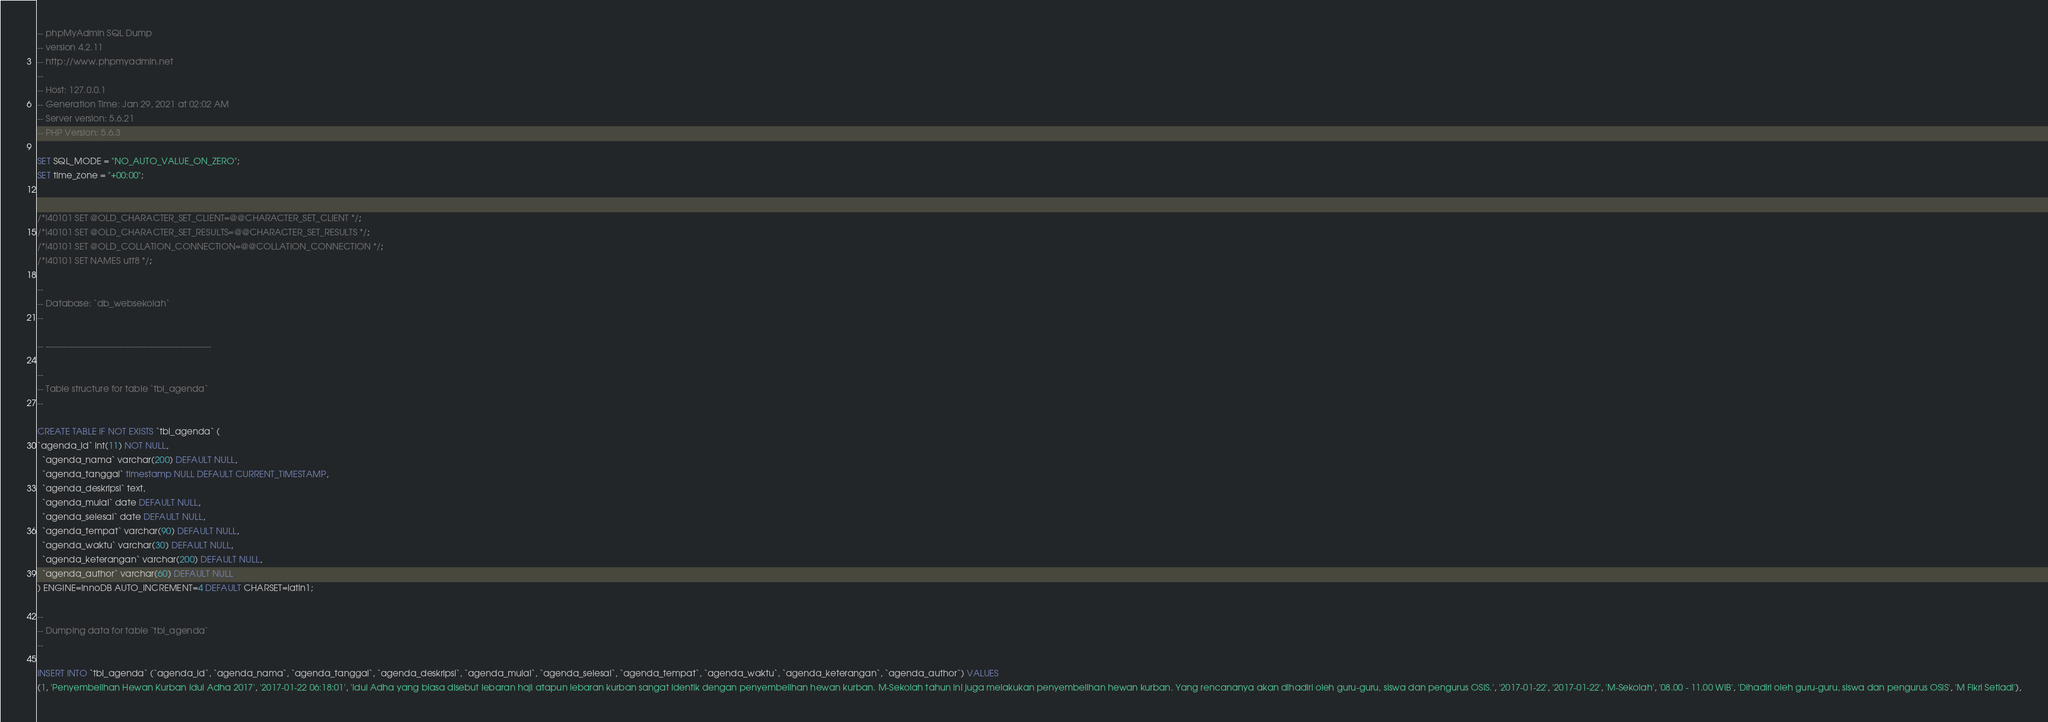Convert code to text. <code><loc_0><loc_0><loc_500><loc_500><_SQL_>-- phpMyAdmin SQL Dump
-- version 4.2.11
-- http://www.phpmyadmin.net
--
-- Host: 127.0.0.1
-- Generation Time: Jan 29, 2021 at 02:02 AM
-- Server version: 5.6.21
-- PHP Version: 5.6.3

SET SQL_MODE = "NO_AUTO_VALUE_ON_ZERO";
SET time_zone = "+00:00";


/*!40101 SET @OLD_CHARACTER_SET_CLIENT=@@CHARACTER_SET_CLIENT */;
/*!40101 SET @OLD_CHARACTER_SET_RESULTS=@@CHARACTER_SET_RESULTS */;
/*!40101 SET @OLD_COLLATION_CONNECTION=@@COLLATION_CONNECTION */;
/*!40101 SET NAMES utf8 */;

--
-- Database: `db_websekolah`
--

-- --------------------------------------------------------

--
-- Table structure for table `tbl_agenda`
--

CREATE TABLE IF NOT EXISTS `tbl_agenda` (
`agenda_id` int(11) NOT NULL,
  `agenda_nama` varchar(200) DEFAULT NULL,
  `agenda_tanggal` timestamp NULL DEFAULT CURRENT_TIMESTAMP,
  `agenda_deskripsi` text,
  `agenda_mulai` date DEFAULT NULL,
  `agenda_selesai` date DEFAULT NULL,
  `agenda_tempat` varchar(90) DEFAULT NULL,
  `agenda_waktu` varchar(30) DEFAULT NULL,
  `agenda_keterangan` varchar(200) DEFAULT NULL,
  `agenda_author` varchar(60) DEFAULT NULL
) ENGINE=InnoDB AUTO_INCREMENT=4 DEFAULT CHARSET=latin1;

--
-- Dumping data for table `tbl_agenda`
--

INSERT INTO `tbl_agenda` (`agenda_id`, `agenda_nama`, `agenda_tanggal`, `agenda_deskripsi`, `agenda_mulai`, `agenda_selesai`, `agenda_tempat`, `agenda_waktu`, `agenda_keterangan`, `agenda_author`) VALUES
(1, 'Penyembelihan Hewan Kurban Idul Adha 2017', '2017-01-22 06:18:01', 'Idul Adha yang biasa disebut lebaran haji atapun lebaran kurban sangat identik dengan penyembelihan hewan kurban. M-Sekolah tahun ini juga melakukan penyembelihan hewan kurban. Yang rencananya akan dihadiri oleh guru-guru, siswa dan pengurus OSIS.', '2017-01-22', '2017-01-22', 'M-Sekolah', '08.00 - 11.00 WIB', 'Dihadiri oleh guru-guru, siswa dan pengurus OSIS', 'M Fikri Setiadi'),</code> 